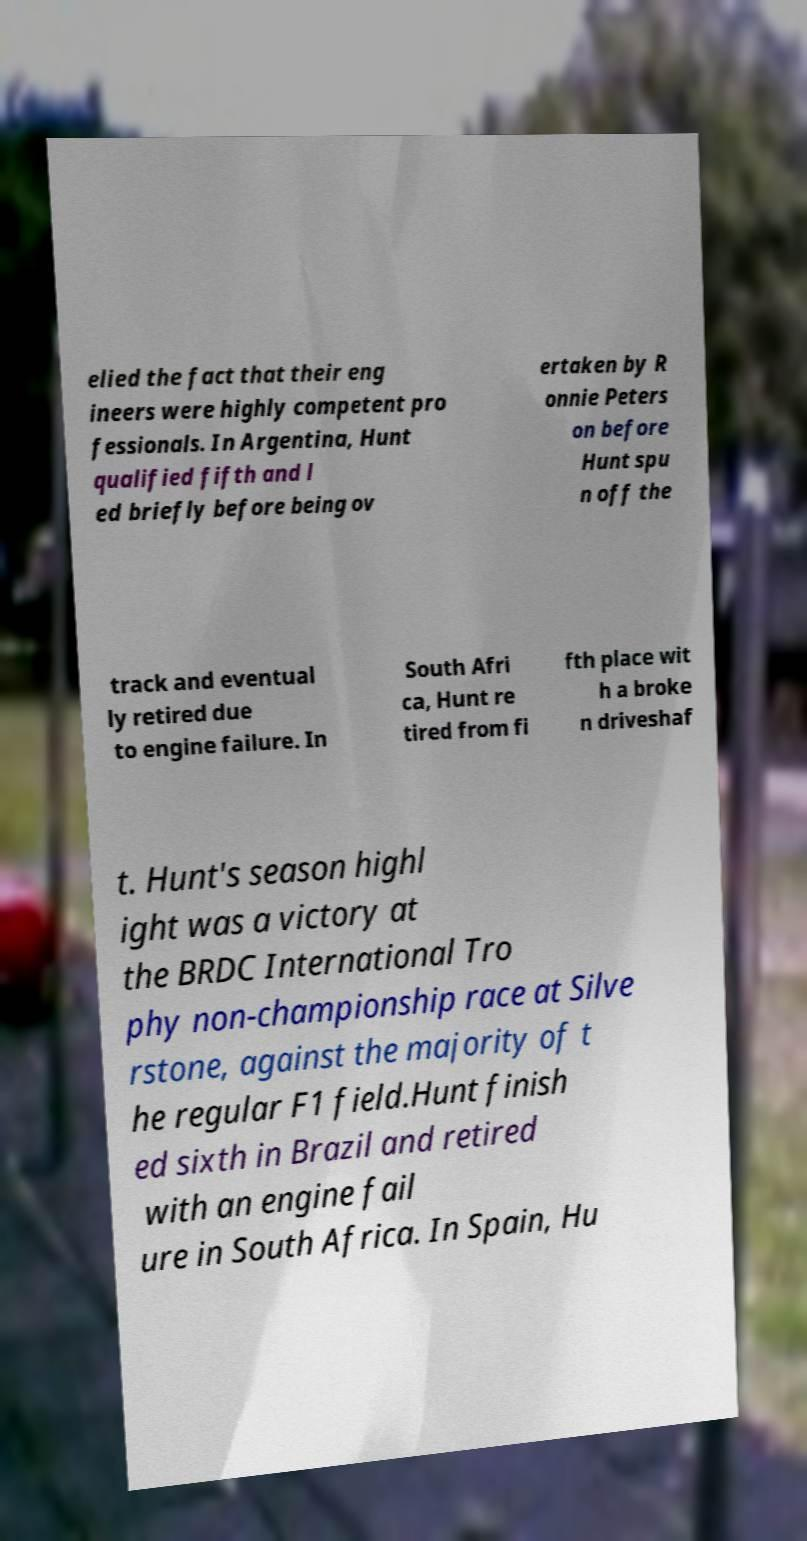Please read and relay the text visible in this image. What does it say? elied the fact that their eng ineers were highly competent pro fessionals. In Argentina, Hunt qualified fifth and l ed briefly before being ov ertaken by R onnie Peters on before Hunt spu n off the track and eventual ly retired due to engine failure. In South Afri ca, Hunt re tired from fi fth place wit h a broke n driveshaf t. Hunt's season highl ight was a victory at the BRDC International Tro phy non-championship race at Silve rstone, against the majority of t he regular F1 field.Hunt finish ed sixth in Brazil and retired with an engine fail ure in South Africa. In Spain, Hu 